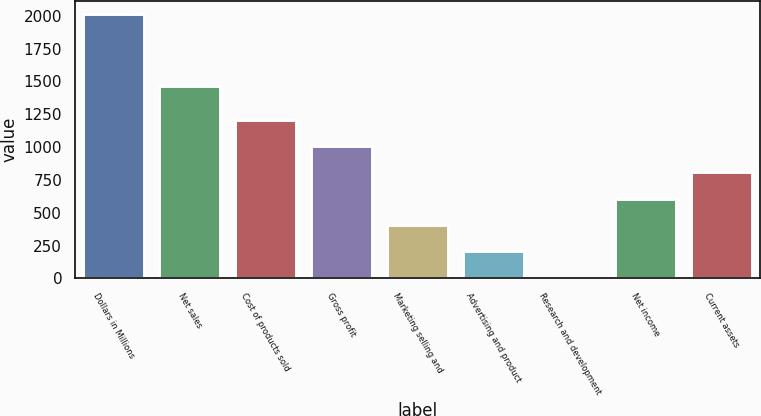<chart> <loc_0><loc_0><loc_500><loc_500><bar_chart><fcel>Dollars in Millions<fcel>Net sales<fcel>Cost of products sold<fcel>Gross profit<fcel>Marketing selling and<fcel>Advertising and product<fcel>Research and development<fcel>Net income<fcel>Current assets<nl><fcel>2011<fcel>1469<fcel>1208.6<fcel>1008<fcel>406.2<fcel>205.6<fcel>5<fcel>606.8<fcel>807.4<nl></chart> 